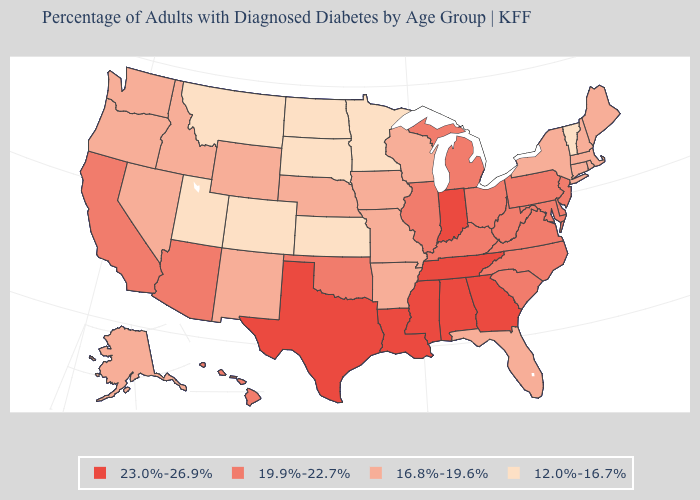What is the lowest value in states that border Maine?
Give a very brief answer. 16.8%-19.6%. Name the states that have a value in the range 16.8%-19.6%?
Quick response, please. Alaska, Arkansas, Connecticut, Florida, Idaho, Iowa, Maine, Massachusetts, Missouri, Nebraska, Nevada, New Hampshire, New Mexico, New York, Oregon, Rhode Island, Washington, Wisconsin, Wyoming. Name the states that have a value in the range 12.0%-16.7%?
Keep it brief. Colorado, Kansas, Minnesota, Montana, North Dakota, South Dakota, Utah, Vermont. Name the states that have a value in the range 12.0%-16.7%?
Be succinct. Colorado, Kansas, Minnesota, Montana, North Dakota, South Dakota, Utah, Vermont. What is the lowest value in states that border Rhode Island?
Keep it brief. 16.8%-19.6%. Name the states that have a value in the range 19.9%-22.7%?
Quick response, please. Arizona, California, Delaware, Hawaii, Illinois, Kentucky, Maryland, Michigan, New Jersey, North Carolina, Ohio, Oklahoma, Pennsylvania, South Carolina, Virginia, West Virginia. Is the legend a continuous bar?
Short answer required. No. What is the value of Oklahoma?
Be succinct. 19.9%-22.7%. What is the value of New Mexico?
Short answer required. 16.8%-19.6%. Name the states that have a value in the range 12.0%-16.7%?
Concise answer only. Colorado, Kansas, Minnesota, Montana, North Dakota, South Dakota, Utah, Vermont. Name the states that have a value in the range 16.8%-19.6%?
Short answer required. Alaska, Arkansas, Connecticut, Florida, Idaho, Iowa, Maine, Massachusetts, Missouri, Nebraska, Nevada, New Hampshire, New Mexico, New York, Oregon, Rhode Island, Washington, Wisconsin, Wyoming. Among the states that border North Carolina , does Tennessee have the highest value?
Answer briefly. Yes. Does North Dakota have the highest value in the USA?
Be succinct. No. Does Montana have the same value as Nevada?
Write a very short answer. No. What is the value of Texas?
Short answer required. 23.0%-26.9%. 